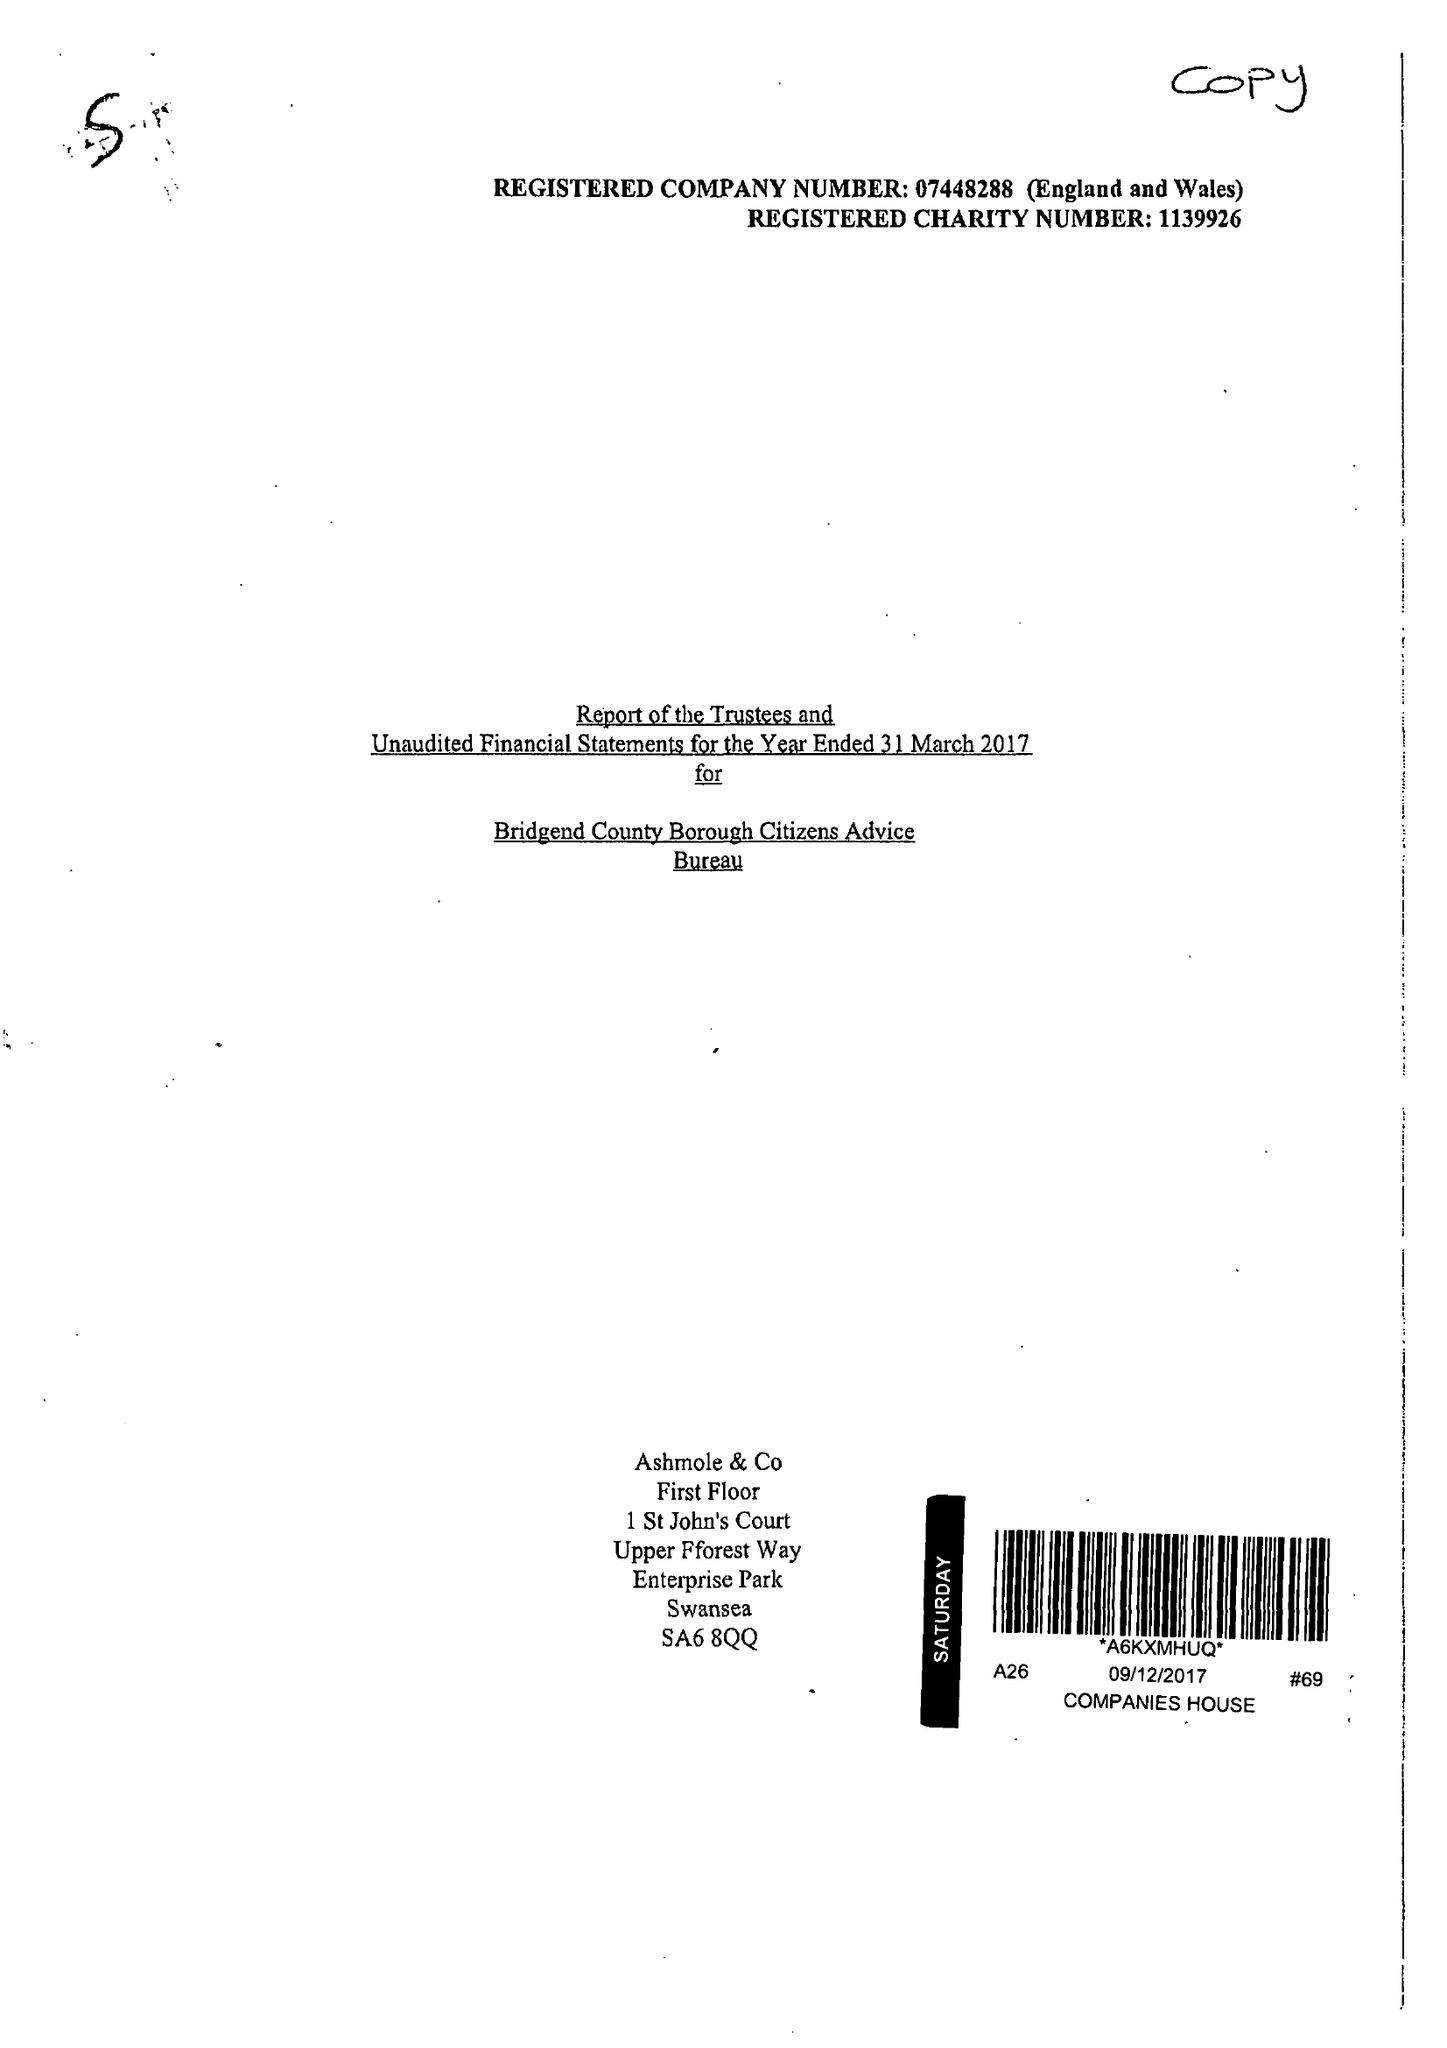What is the value for the report_date?
Answer the question using a single word or phrase. 2017-03-31 